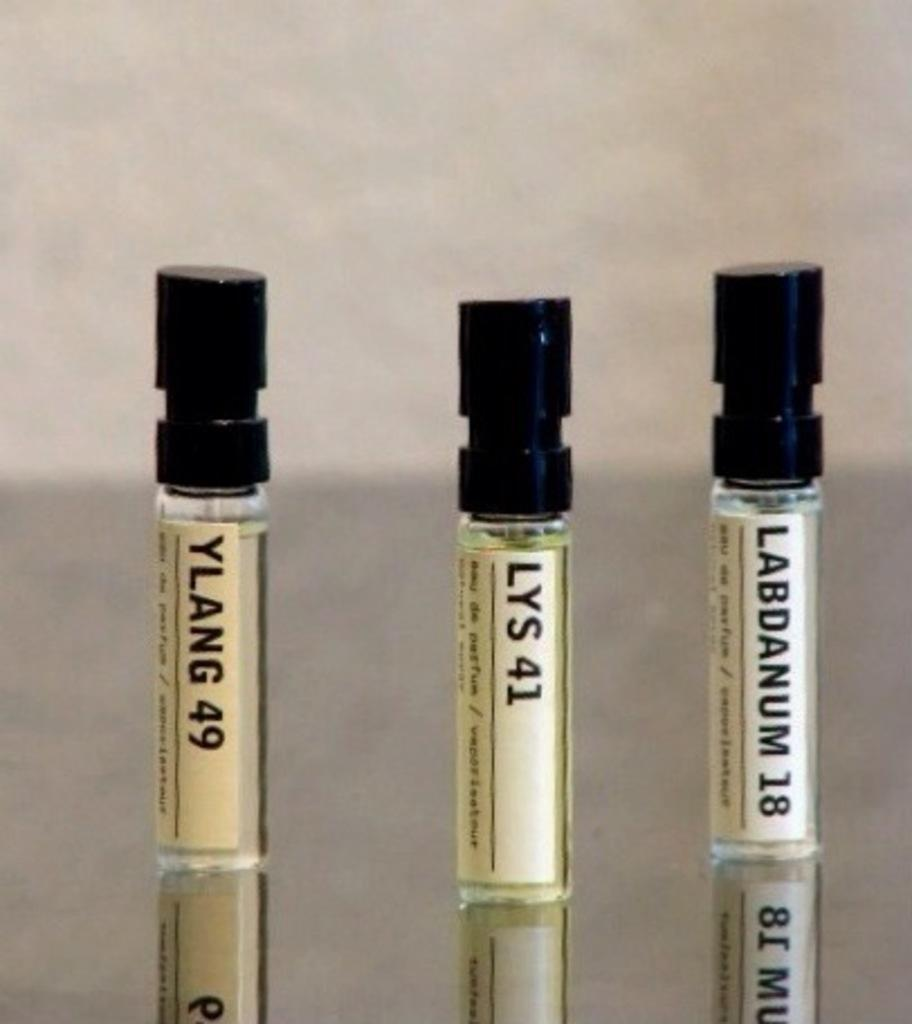<image>
Give a short and clear explanation of the subsequent image. Three vials with Ylang 49, Lys 41 and Labdanum 18 written on them. 